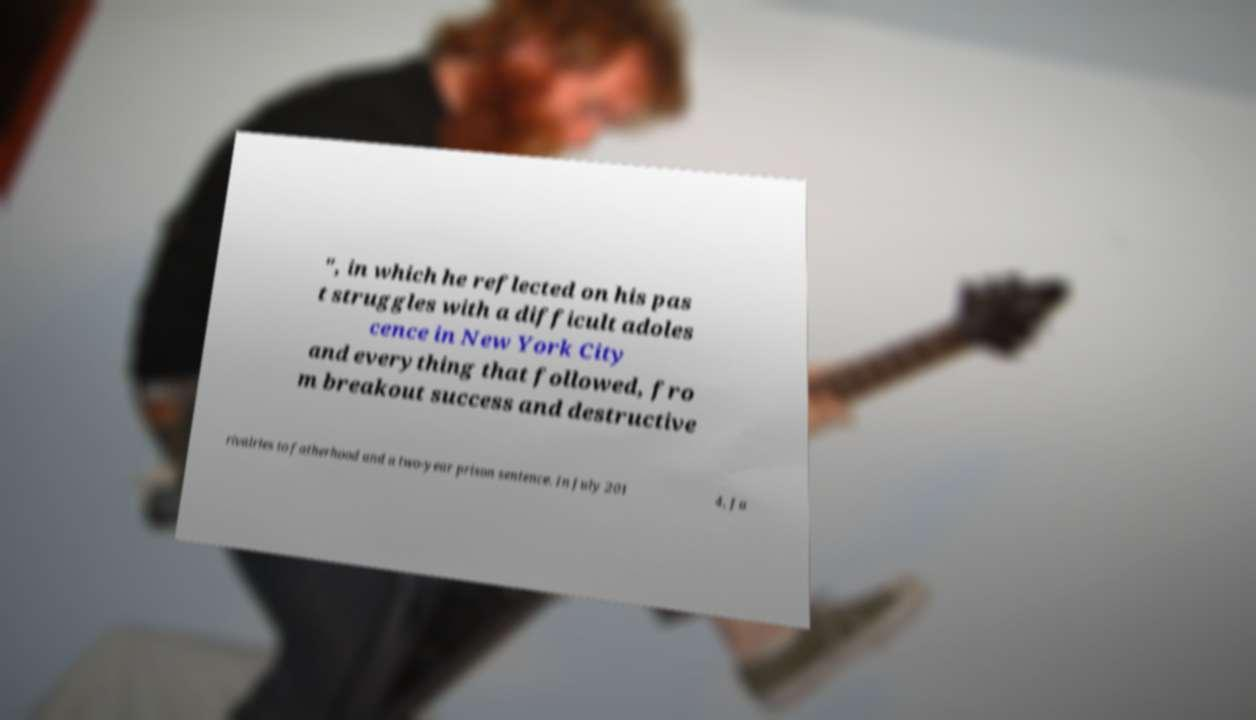What messages or text are displayed in this image? I need them in a readable, typed format. ", in which he reflected on his pas t struggles with a difficult adoles cence in New York City and everything that followed, fro m breakout success and destructive rivalries to fatherhood and a two-year prison sentence. In July 201 4, Ja 